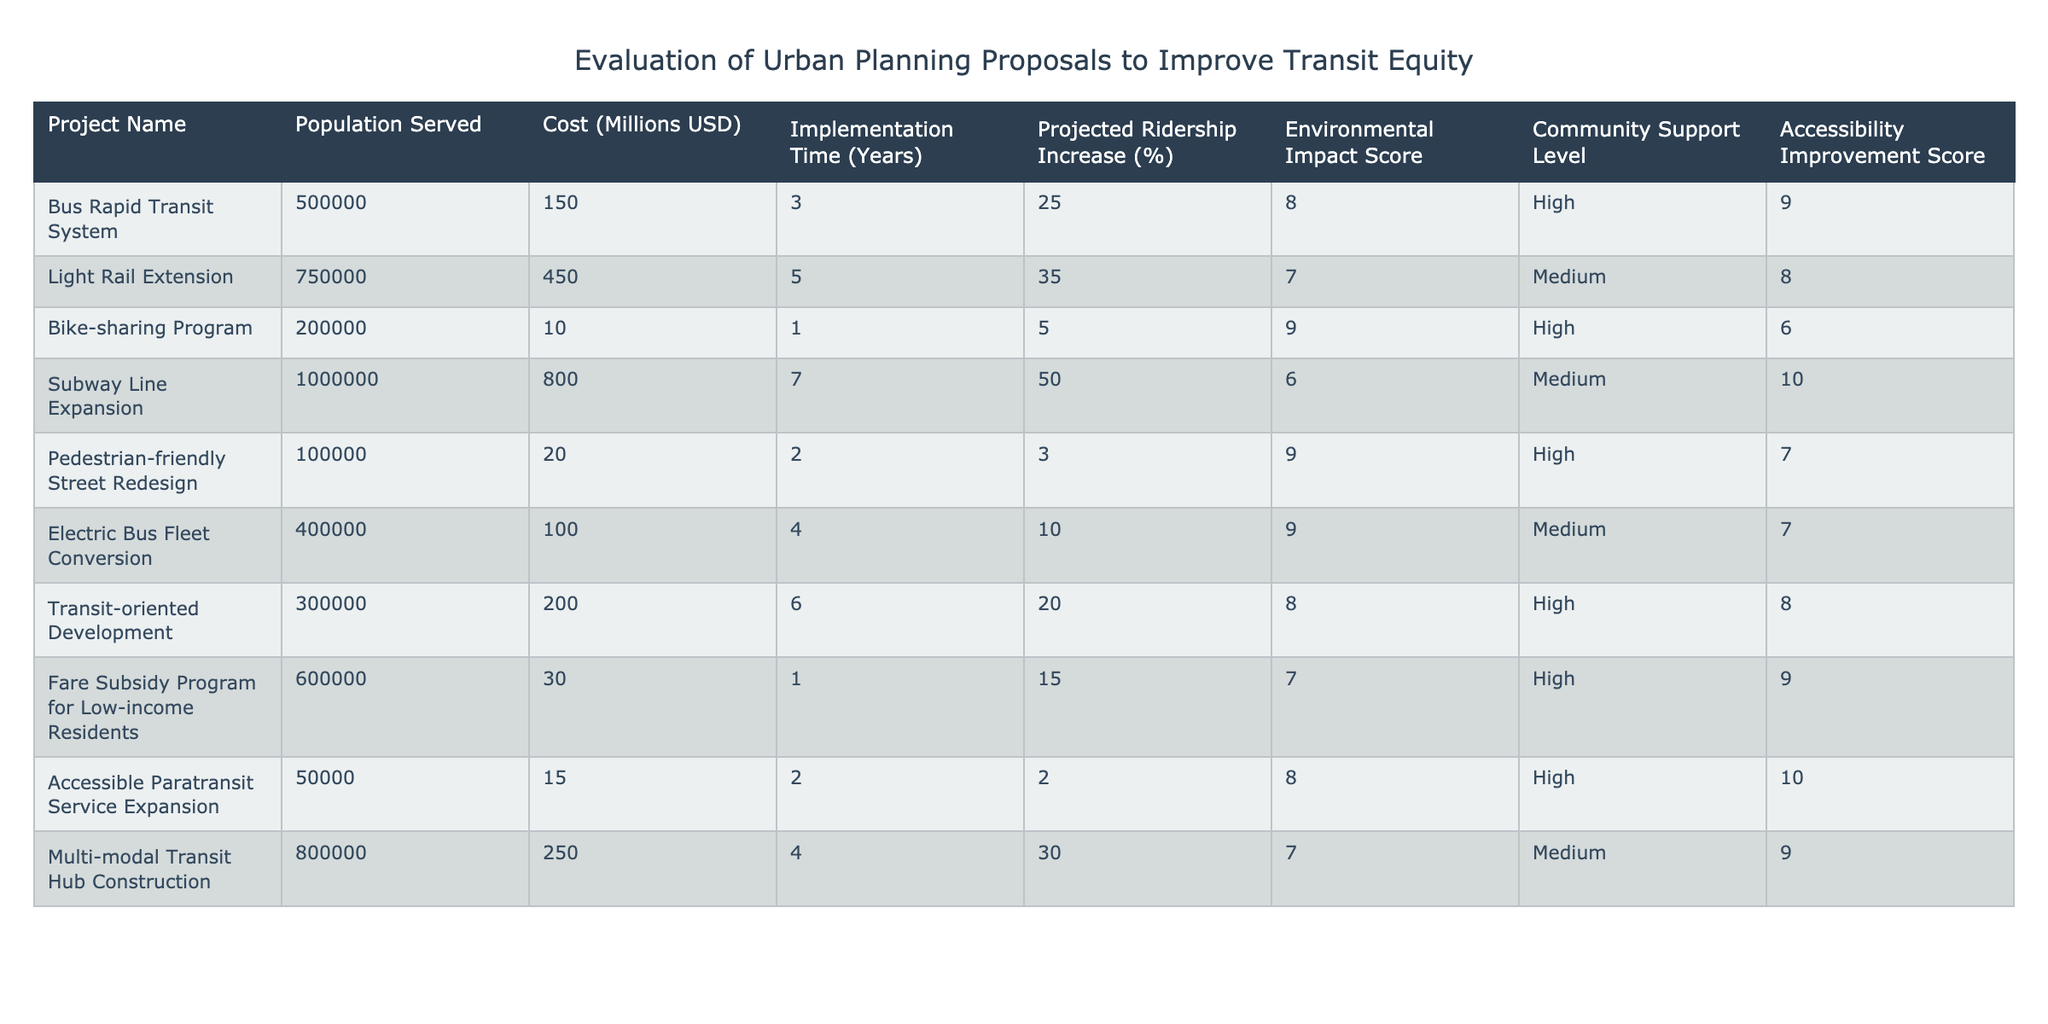What is the projected ridership increase for the Light Rail Extension project? The projected ridership increase for the Light Rail Extension is stated in the table as 35%.
Answer: 35% Which project has the highest population served? The project with the highest population served is the Subway Line Expansion, which serves 1,000,000 people, as noted in the Population Served column.
Answer: Subway Line Expansion What is the average cost of the projects listed in the table? To calculate the average cost, sum all the costs: 150 + 450 + 10 + 800 + 20 + 100 + 200 + 30 + 15 + 250 = 2025 million USD. Then divide by the number of projects (10): 2025 / 10 = 202.5 million USD.
Answer: 202.5 million USD Is the Community Support Level for the Bike-sharing Program High? According to the table, the Community Support Level for the Bike-sharing Program is noted as High.
Answer: Yes Which project has the lowest Environmental Impact Score, and what is that score? The project with the lowest Environmental Impact Score is the Subway Line Expansion, which has a score of 6. This information can be found by comparing all the Environmental Impact Scores in the corresponding column.
Answer: Subway Line Expansion, 6 What is the total cost of projects that have High Community Support? To find the total cost, identify projects with High Community Support: Bus Rapid Transit System (150), Bike-sharing Program (10), Pedestrian-friendly Street Redesign (20), Fare Subsidy Program (30), Accessible Paratransit Service Expansion (15), and Transit-oriented Development (200). Add these costs: 150 + 10 + 20 + 30 + 15 + 200 = 425 million USD.
Answer: 425 million USD How many years does it take to implement the project with the highest Accessibility Improvement Score? The project with the highest Accessibility Improvement Score is the Accessible Paratransit Service Expansion, which has a score of 10. The Implementation Time for this project is listed as 2 years in the corresponding column.
Answer: 2 years Which project increases ridership by 30% or more while also maintaining a cost of less than 300 million USD? The project that meets these criteria is the Light Rail Extension, which increases ridership by 35% and costs 450 million USD. However, this does not satisfy the cost condition. The next best is the Multi-modal Transit Hub Construction, which increases ridership by 30% and costs 250 million USD, thus fulfilling both criteria when considering acceptable cost limits.
Answer: None What project has the most significant difference between its Cost and Accessibility Improvement Score? To find the project with the most significant difference, calculate the difference for each project. For the Subway Line Expansion, the difference is 800 - 10 = 790, and for the Bus Rapid Transit System, it's 150 - 9 = 141. The Subway Line Expansion has the largest difference, with a calculated difference of 790 (Cost minus Accessibility Improvement Score).
Answer: Subway Line Expansion, 790 